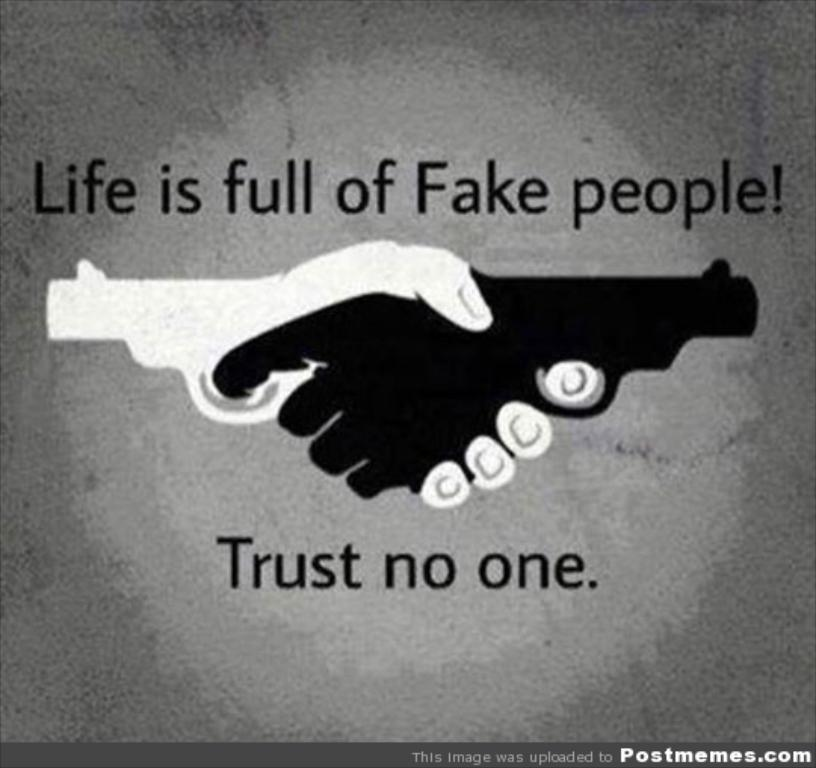<image>
Summarize the visual content of the image. A poster warning readers that they should trust no one 